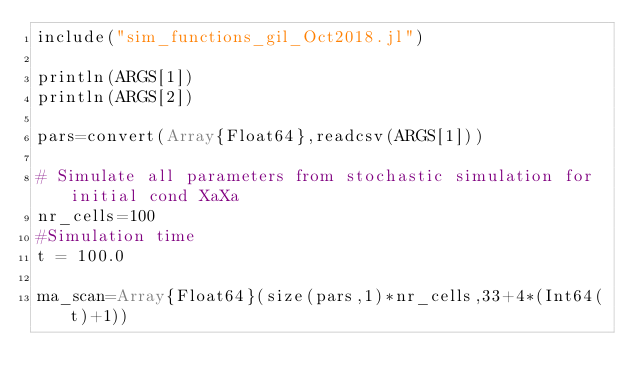<code> <loc_0><loc_0><loc_500><loc_500><_Julia_>include("sim_functions_gil_Oct2018.jl")

println(ARGS[1])
println(ARGS[2])

pars=convert(Array{Float64},readcsv(ARGS[1]))

# Simulate all parameters from stochastic simulation for initial cond XaXa
nr_cells=100
#Simulation time
t = 100.0

ma_scan=Array{Float64}(size(pars,1)*nr_cells,33+4*(Int64(t)+1))</code> 